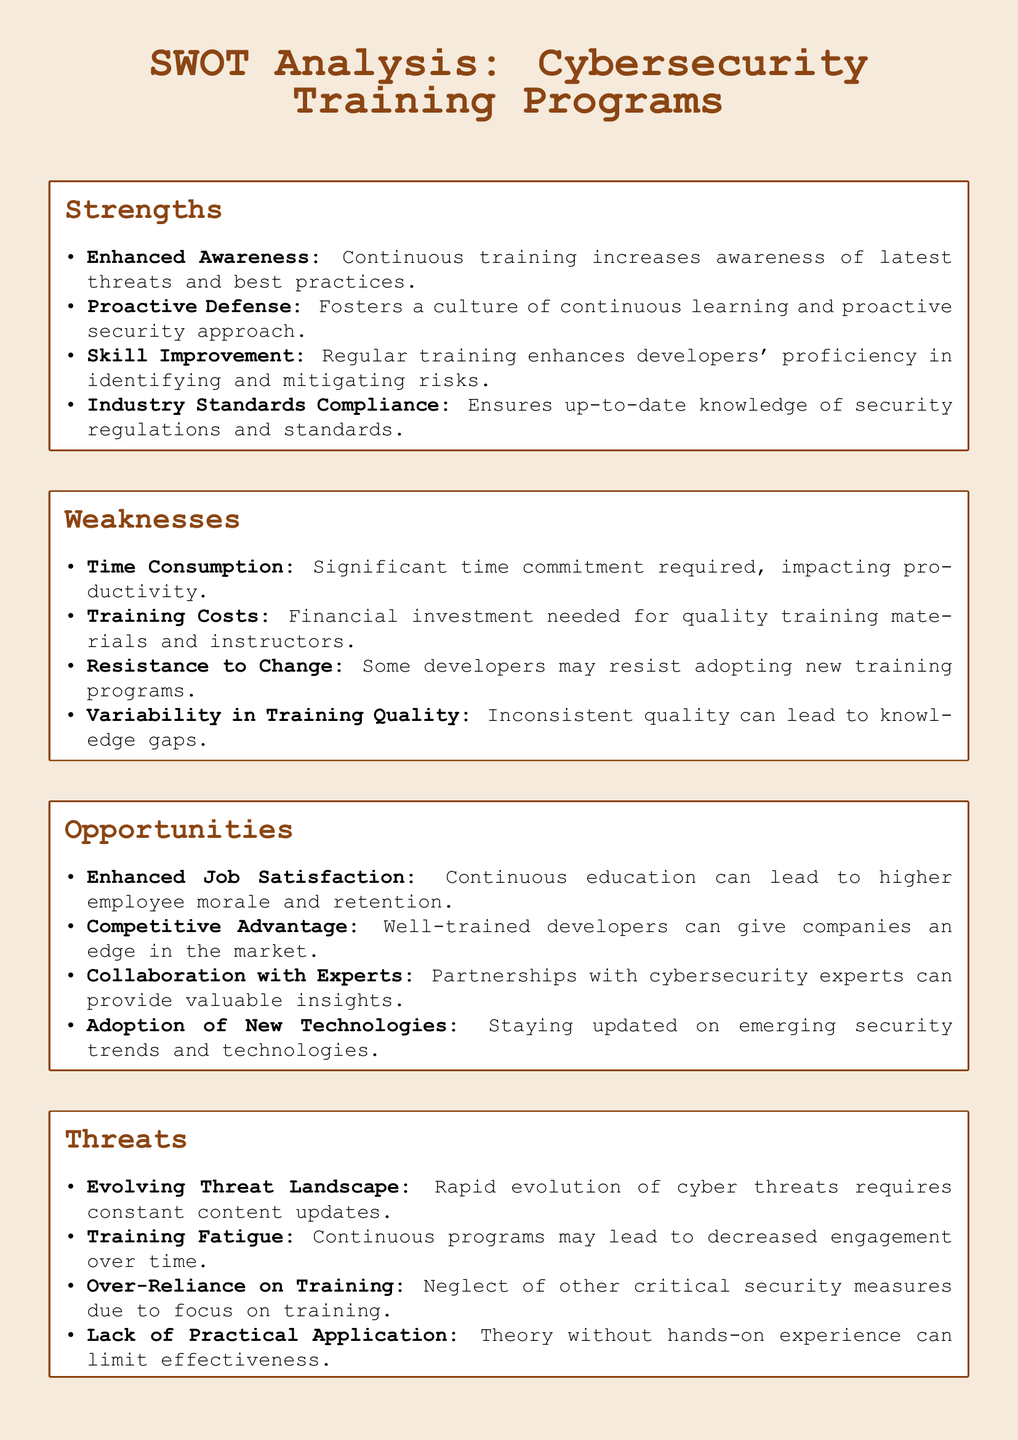What are the strengths of cybersecurity training programs? The strengths are listed under the strengths section of the SWOT analysis, highlighting their benefits.
Answer: Enhanced Awareness, Proactive Defense, Skill Improvement, Industry Standards Compliance What is one weakness related to training? A weakness is listed in the weaknesses section, which highlights potential drawbacks of training.
Answer: Time Consumption How many opportunities are identified in the document? The opportunities section lists multiple opportunities, specifically four unique advantages.
Answer: Four What is a threat associated with evolving technology? A specific threat related to the changing cybersecurity environment is categorized under threats, detailing risks.
Answer: Evolving Threat Landscape Which stakeholder might provide valuable insights to training programs? The document notes that collaboration with a certain type of professional can enhance training effectiveness.
Answer: Cybersecurity experts What aspect might decrease engagement over time in training programs? The document discusses a phenomenon that can affect how users interact with continuous education.
Answer: Training Fatigue What is an example of a reason developers might resist new training programs? The document points out a psychological factor that can lead to opposition in adopting new educational initiatives.
Answer: Resistance to Change What does the document say about the impact of training on employee morale? It states a positive effect that continuous education can have on the overall workplace environment.
Answer: Enhanced Job Satisfaction What might hinder the effectiveness of theoretical training? The document highlights a potential limitation of educational approaches that lack practical elements.
Answer: Lack of Practical Application 